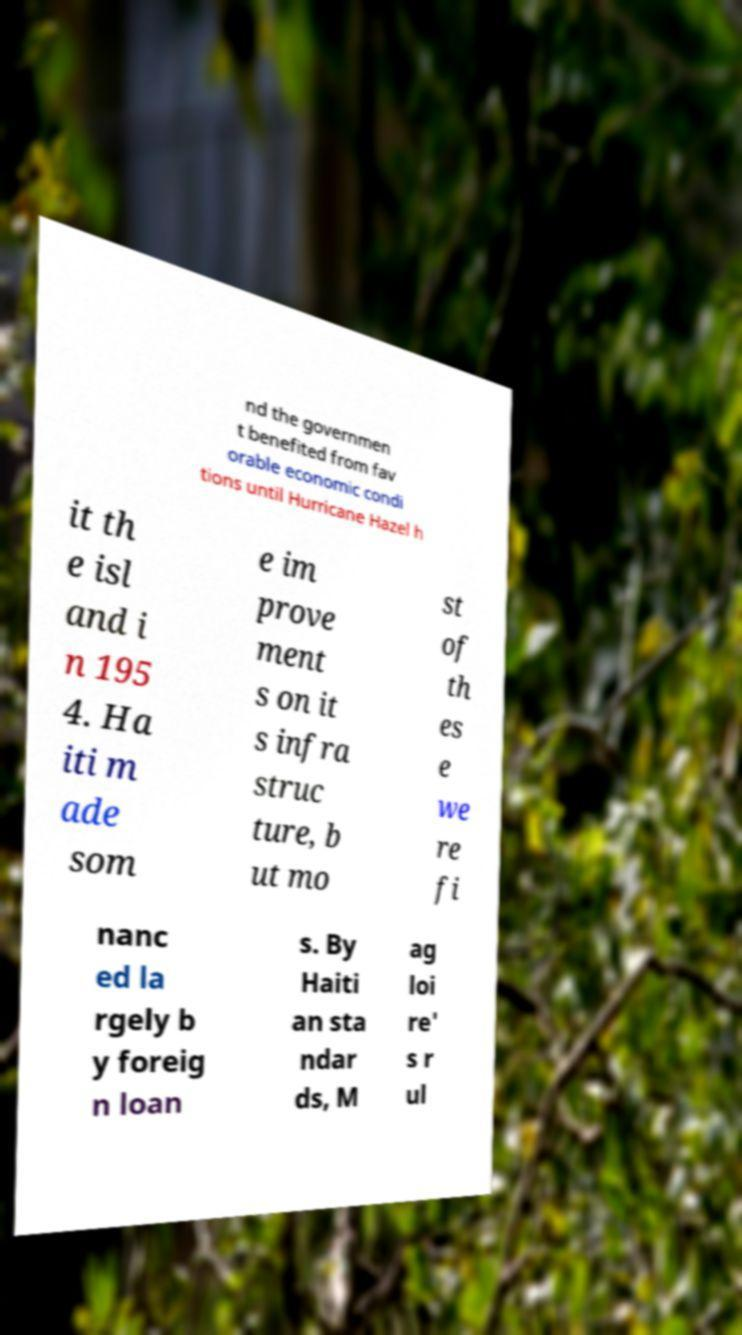Please identify and transcribe the text found in this image. nd the governmen t benefited from fav orable economic condi tions until Hurricane Hazel h it th e isl and i n 195 4. Ha iti m ade som e im prove ment s on it s infra struc ture, b ut mo st of th es e we re fi nanc ed la rgely b y foreig n loan s. By Haiti an sta ndar ds, M ag loi re' s r ul 